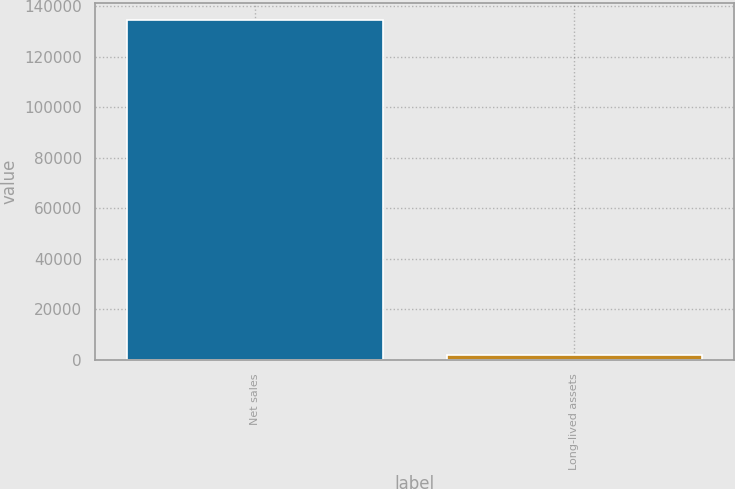<chart> <loc_0><loc_0><loc_500><loc_500><bar_chart><fcel>Net sales<fcel>Long-lived assets<nl><fcel>134638<fcel>1862<nl></chart> 